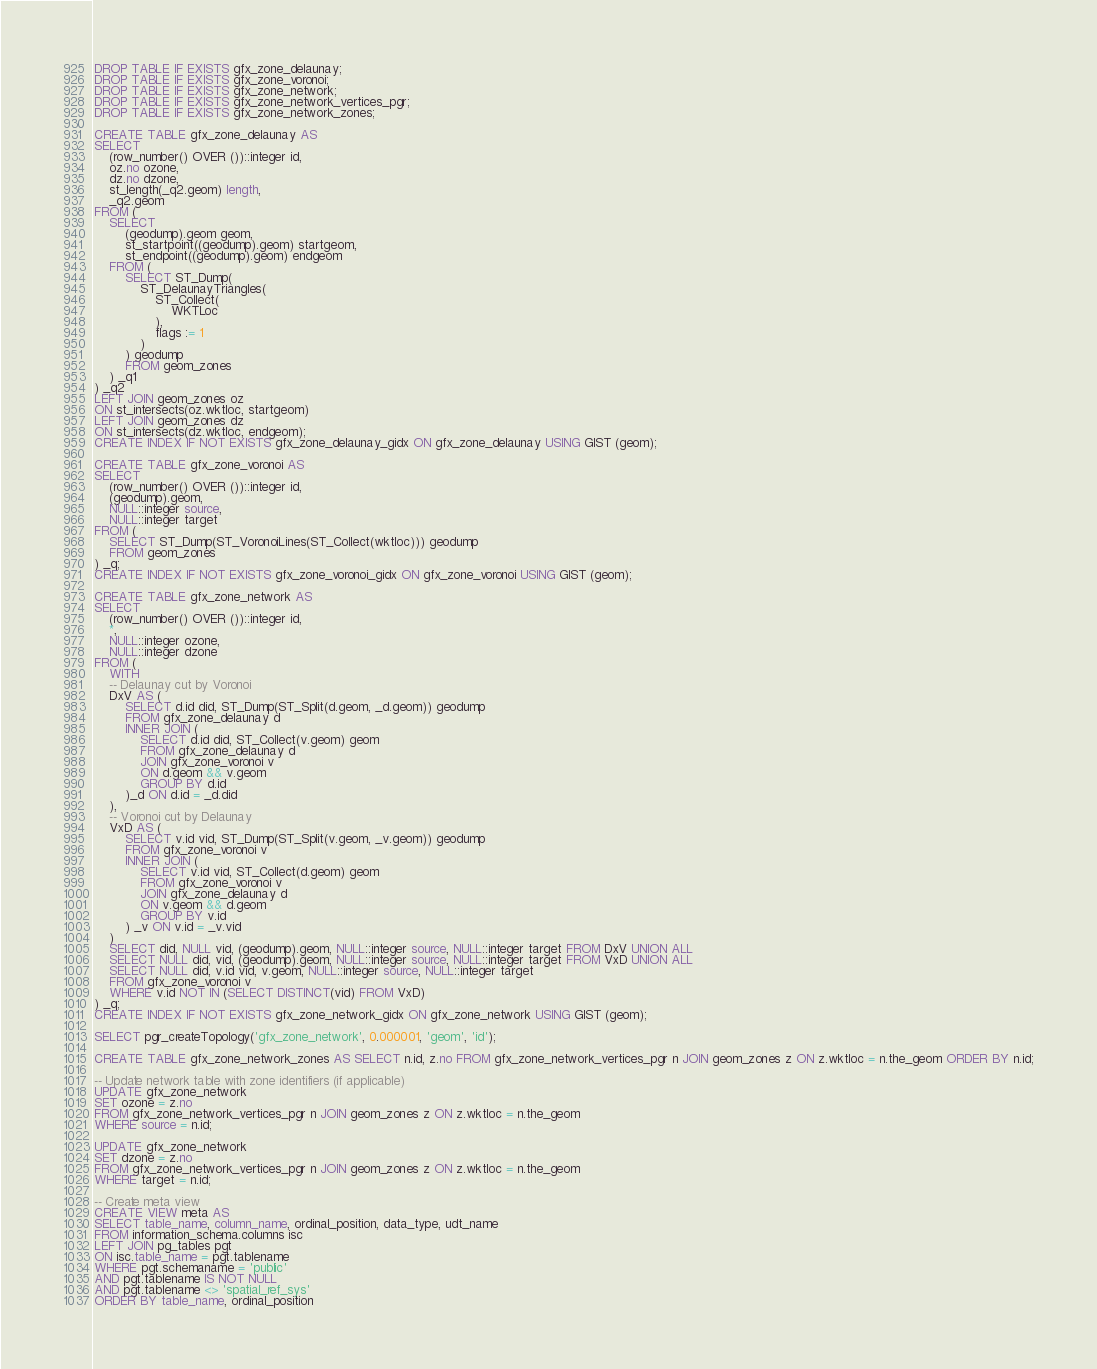Convert code to text. <code><loc_0><loc_0><loc_500><loc_500><_SQL_>DROP TABLE IF EXISTS gfx_zone_delaunay;
DROP TABLE IF EXISTS gfx_zone_voronoi;
DROP TABLE IF EXISTS gfx_zone_network;
DROP TABLE IF EXISTS gfx_zone_network_vertices_pgr;
DROP TABLE IF EXISTS gfx_zone_network_zones;

CREATE TABLE gfx_zone_delaunay AS
SELECT
    (row_number() OVER ())::integer id,
    oz.no ozone,
    dz.no dzone,
    st_length(_q2.geom) length,
    _q2.geom
FROM (
    SELECT
        (geodump).geom geom,
        st_startpoint((geodump).geom) startgeom,
        st_endpoint((geodump).geom) endgeom
    FROM (
        SELECT ST_Dump(
            ST_DelaunayTriangles(
                ST_Collect(
                    WKTLoc
                ),
                flags := 1
            )
        ) geodump
        FROM geom_zones
    ) _q1
) _q2
LEFT JOIN geom_zones oz
ON st_intersects(oz.wktloc, startgeom)
LEFT JOIN geom_zones dz
ON st_intersects(dz.wktloc, endgeom);
CREATE INDEX IF NOT EXISTS gfx_zone_delaunay_gidx ON gfx_zone_delaunay USING GIST (geom);

CREATE TABLE gfx_zone_voronoi AS
SELECT
    (row_number() OVER ())::integer id,
    (geodump).geom,
    NULL::integer source,
    NULL::integer target
FROM (
    SELECT ST_Dump(ST_VoronoiLines(ST_Collect(wktloc))) geodump
    FROM geom_zones
) _q;
CREATE INDEX IF NOT EXISTS gfx_zone_voronoi_gidx ON gfx_zone_voronoi USING GIST (geom);

CREATE TABLE gfx_zone_network AS
SELECT
    (row_number() OVER ())::integer id,
    *,
    NULL::integer ozone,
    NULL::integer dzone
FROM (
    WITH
    -- Delaunay cut by Voronoi
    DxV AS (
        SELECT d.id did, ST_Dump(ST_Split(d.geom, _d.geom)) geodump
        FROM gfx_zone_delaunay d
        INNER JOIN (
            SELECT d.id did, ST_Collect(v.geom) geom
            FROM gfx_zone_delaunay d
            JOIN gfx_zone_voronoi v
            ON d.geom && v.geom
            GROUP BY d.id
        )_d ON d.id = _d.did
    ),
    -- Voronoi cut by Delaunay
    VxD AS (
        SELECT v.id vid, ST_Dump(ST_Split(v.geom, _v.geom)) geodump
        FROM gfx_zone_voronoi v
        INNER JOIN (
            SELECT v.id vid, ST_Collect(d.geom) geom
            FROM gfx_zone_voronoi v
            JOIN gfx_zone_delaunay d
            ON v.geom && d.geom
            GROUP BY v.id
        ) _v ON v.id = _v.vid
    )
    SELECT did, NULL vid, (geodump).geom, NULL::integer source, NULL::integer target FROM DxV UNION ALL
    SELECT NULL did, vid, (geodump).geom, NULL::integer source, NULL::integer target FROM VxD UNION ALL
    SELECT NULL did, v.id vid, v.geom, NULL::integer source, NULL::integer target
    FROM gfx_zone_voronoi v
    WHERE v.id NOT IN (SELECT DISTINCT(vid) FROM VxD)
) _q;
CREATE INDEX IF NOT EXISTS gfx_zone_network_gidx ON gfx_zone_network USING GIST (geom);

SELECT pgr_createTopology('gfx_zone_network', 0.000001, 'geom', 'id');

CREATE TABLE gfx_zone_network_zones AS SELECT n.id, z.no FROM gfx_zone_network_vertices_pgr n JOIN geom_zones z ON z.wktloc = n.the_geom ORDER BY n.id;

-- Update network table with zone identifiers (if applicable)
UPDATE gfx_zone_network
SET ozone = z.no
FROM gfx_zone_network_vertices_pgr n JOIN geom_zones z ON z.wktloc = n.the_geom
WHERE source = n.id;

UPDATE gfx_zone_network
SET dzone = z.no
FROM gfx_zone_network_vertices_pgr n JOIN geom_zones z ON z.wktloc = n.the_geom
WHERE target = n.id;

-- Create meta view
CREATE VIEW meta AS
SELECT table_name, column_name, ordinal_position, data_type, udt_name
FROM information_schema.columns isc
LEFT JOIN pg_tables pgt
ON isc.table_name = pgt.tablename
WHERE pgt.schemaname = 'public'
AND pgt.tablename IS NOT NULL
AND pgt.tablename <> 'spatial_ref_sys'
ORDER BY table_name, ordinal_position</code> 